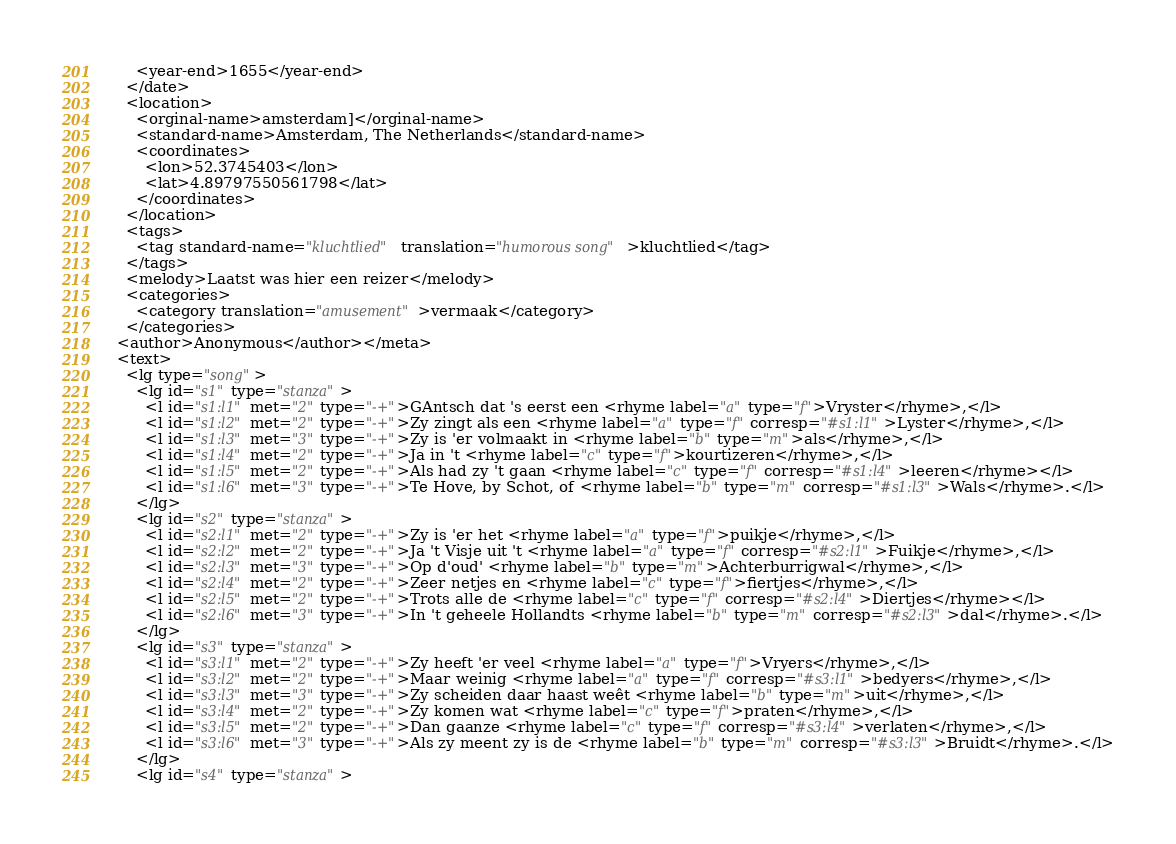<code> <loc_0><loc_0><loc_500><loc_500><_XML_>      <year-end>1655</year-end>
    </date>
    <location>
      <orginal-name>amsterdam]</orginal-name>
      <standard-name>Amsterdam, The Netherlands</standard-name>
      <coordinates>
        <lon>52.3745403</lon>
        <lat>4.89797550561798</lat>
      </coordinates>
    </location>
    <tags>
      <tag standard-name="kluchtlied" translation="humorous song">kluchtlied</tag>
    </tags>
    <melody>Laatst was hier een reizer</melody>
    <categories>
      <category translation="amusement">vermaak</category>
    </categories>
  <author>Anonymous</author></meta>
  <text>
    <lg type="song">
      <lg id="s1" type="stanza">
        <l id="s1:l1" met="2" type="-+">GAntsch dat 's eerst een <rhyme label="a" type="f">Vryster</rhyme>,</l>
        <l id="s1:l2" met="2" type="-+">Zy zingt als een <rhyme label="a" type="f" corresp="#s1:l1">Lyster</rhyme>,</l>
        <l id="s1:l3" met="3" type="-+">Zy is 'er volmaakt in <rhyme label="b" type="m">als</rhyme>,</l>
        <l id="s1:l4" met="2" type="-+">Ja in 't <rhyme label="c" type="f">kourtizeren</rhyme>,</l>
        <l id="s1:l5" met="2" type="-+">Als had zy 't gaan <rhyme label="c" type="f" corresp="#s1:l4">leeren</rhyme></l>
        <l id="s1:l6" met="3" type="-+">Te Hove, by Schot, of <rhyme label="b" type="m" corresp="#s1:l3">Wals</rhyme>.</l>
      </lg>
      <lg id="s2" type="stanza">
        <l id="s2:l1" met="2" type="-+">Zy is 'er het <rhyme label="a" type="f">puikje</rhyme>,</l>
        <l id="s2:l2" met="2" type="-+">Ja 't Visje uit 't <rhyme label="a" type="f" corresp="#s2:l1">Fuikje</rhyme>,</l>
        <l id="s2:l3" met="3" type="-+">Op d'oud' <rhyme label="b" type="m">Achterburrigwal</rhyme>,</l>
        <l id="s2:l4" met="2" type="-+">Zeer netjes en <rhyme label="c" type="f">fiertjes</rhyme>,</l>
        <l id="s2:l5" met="2" type="-+">Trots alle de <rhyme label="c" type="f" corresp="#s2:l4">Diertjes</rhyme></l>
        <l id="s2:l6" met="3" type="-+">In 't geheele Hollandts <rhyme label="b" type="m" corresp="#s2:l3">dal</rhyme>.</l>
      </lg>
      <lg id="s3" type="stanza">
        <l id="s3:l1" met="2" type="-+">Zy heeft 'er veel <rhyme label="a" type="f">Vryers</rhyme>,</l>
        <l id="s3:l2" met="2" type="-+">Maar weinig <rhyme label="a" type="f" corresp="#s3:l1">bedyers</rhyme>,</l>
        <l id="s3:l3" met="3" type="-+">Zy scheiden daar haast weêt <rhyme label="b" type="m">uit</rhyme>,</l>
        <l id="s3:l4" met="2" type="-+">Zy komen wat <rhyme label="c" type="f">praten</rhyme>,</l>
        <l id="s3:l5" met="2" type="-+">Dan gaanze <rhyme label="c" type="f" corresp="#s3:l4">verlaten</rhyme>,</l>
        <l id="s3:l6" met="3" type="-+">Als zy meent zy is de <rhyme label="b" type="m" corresp="#s3:l3">Bruidt</rhyme>.</l>
      </lg>
      <lg id="s4" type="stanza"></code> 